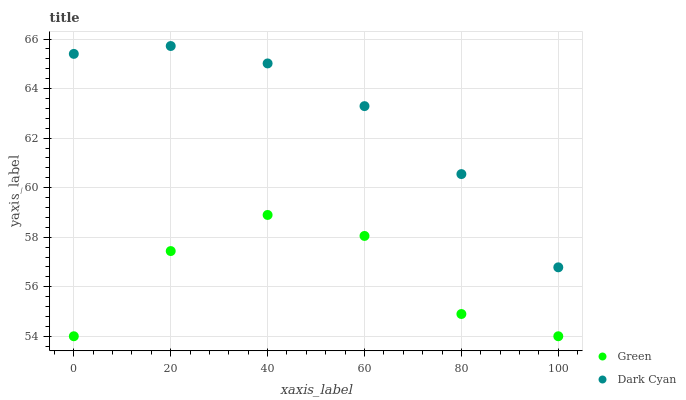Does Green have the minimum area under the curve?
Answer yes or no. Yes. Does Dark Cyan have the maximum area under the curve?
Answer yes or no. Yes. Does Green have the maximum area under the curve?
Answer yes or no. No. Is Dark Cyan the smoothest?
Answer yes or no. Yes. Is Green the roughest?
Answer yes or no. Yes. Is Green the smoothest?
Answer yes or no. No. Does Green have the lowest value?
Answer yes or no. Yes. Does Dark Cyan have the highest value?
Answer yes or no. Yes. Does Green have the highest value?
Answer yes or no. No. Is Green less than Dark Cyan?
Answer yes or no. Yes. Is Dark Cyan greater than Green?
Answer yes or no. Yes. Does Green intersect Dark Cyan?
Answer yes or no. No. 